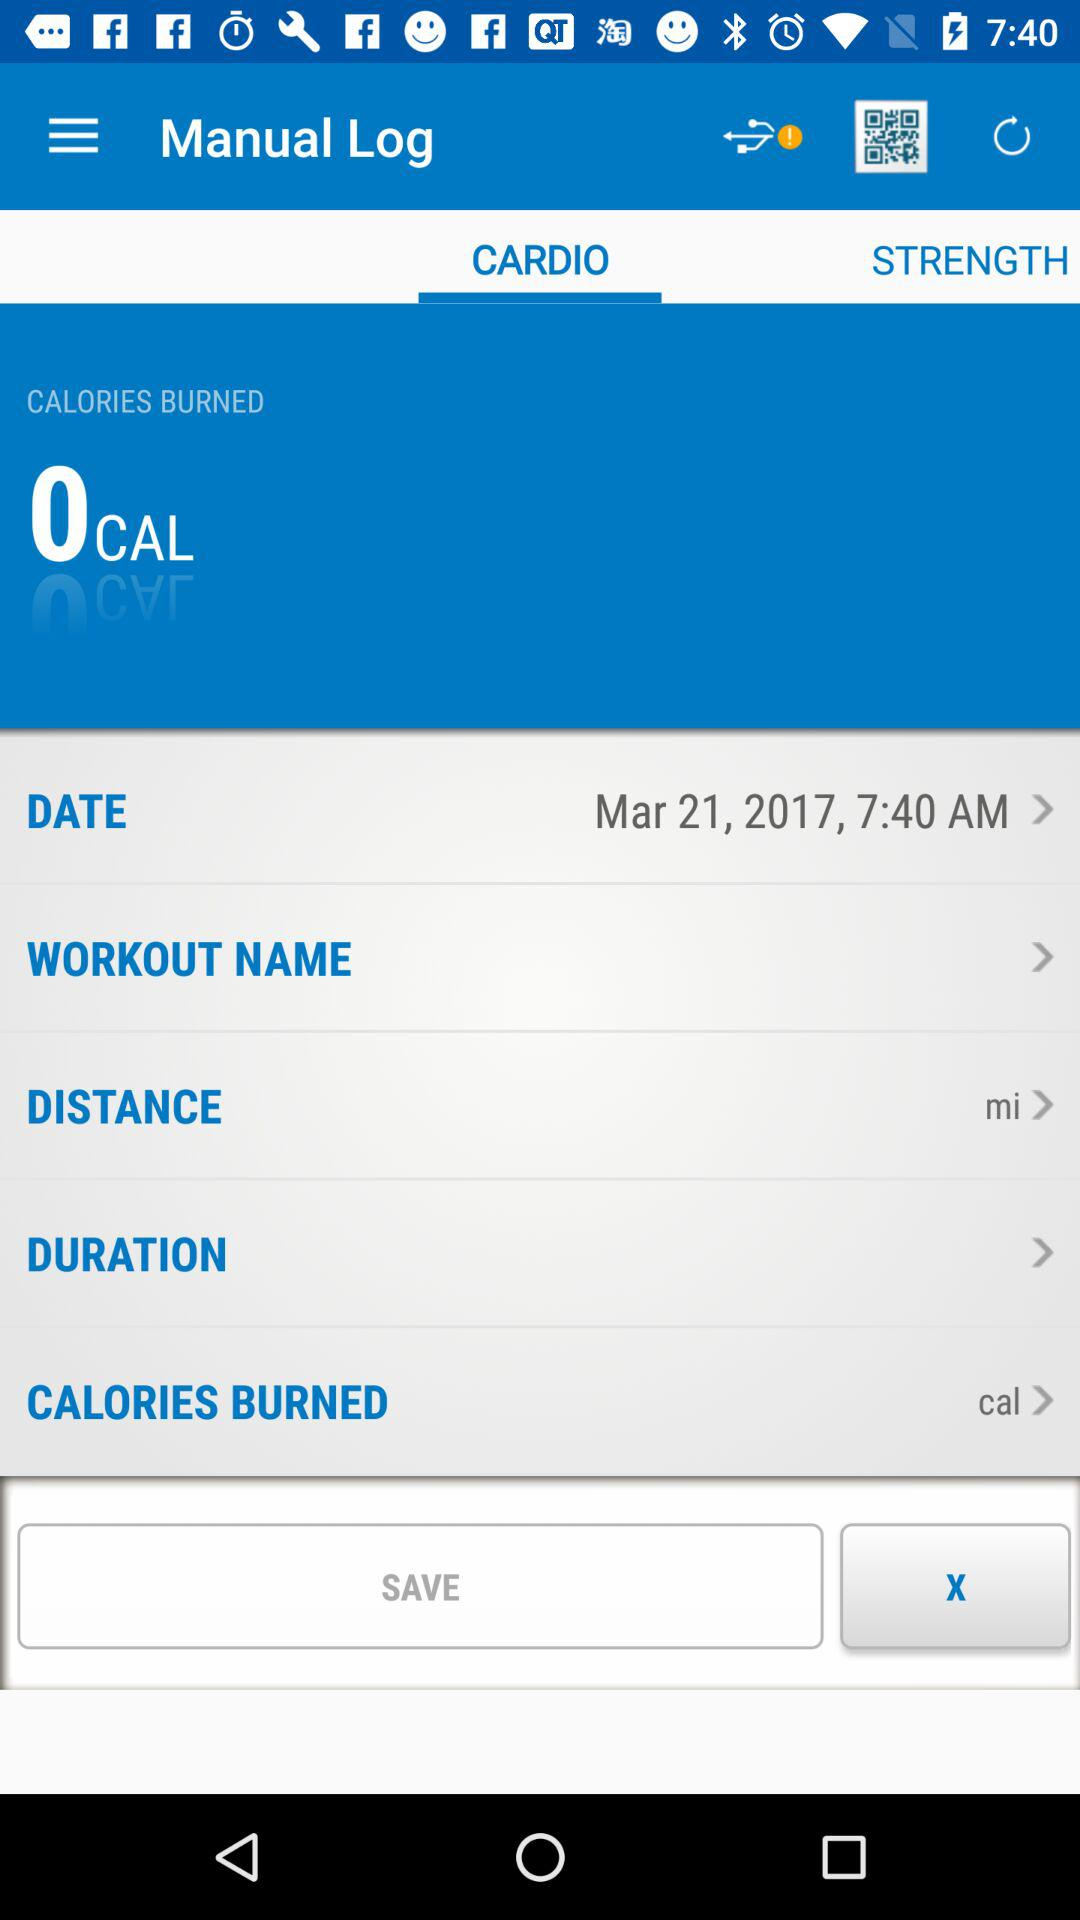What is the time? The time is 7:40 a.m. 